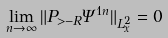<formula> <loc_0><loc_0><loc_500><loc_500>\lim _ { n \to \infty } \| P _ { > - R } \Psi ^ { 1 n } \| _ { L _ { x } ^ { 2 } } = 0</formula> 